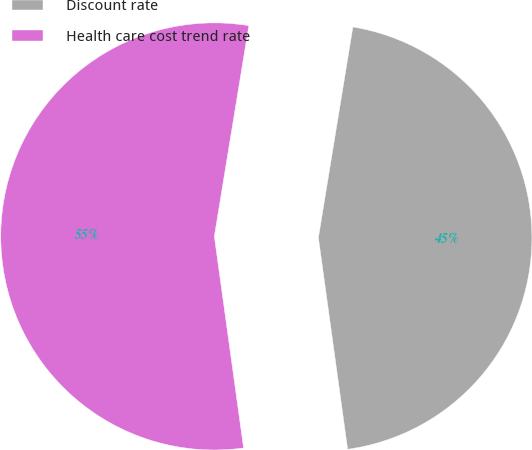Convert chart. <chart><loc_0><loc_0><loc_500><loc_500><pie_chart><fcel>Discount rate<fcel>Health care cost trend rate<nl><fcel>45.23%<fcel>54.77%<nl></chart> 